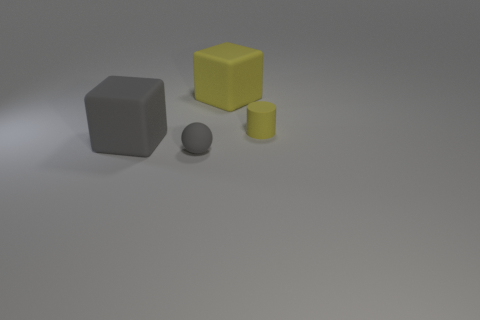Add 2 tiny matte blocks. How many objects exist? 6 Subtract all cyan spheres. Subtract all green cylinders. How many spheres are left? 1 Subtract all balls. How many objects are left? 3 Subtract 0 blue balls. How many objects are left? 4 Subtract all tiny brown rubber cubes. Subtract all tiny gray balls. How many objects are left? 3 Add 3 tiny rubber cylinders. How many tiny rubber cylinders are left? 4 Add 2 tiny metal cylinders. How many tiny metal cylinders exist? 2 